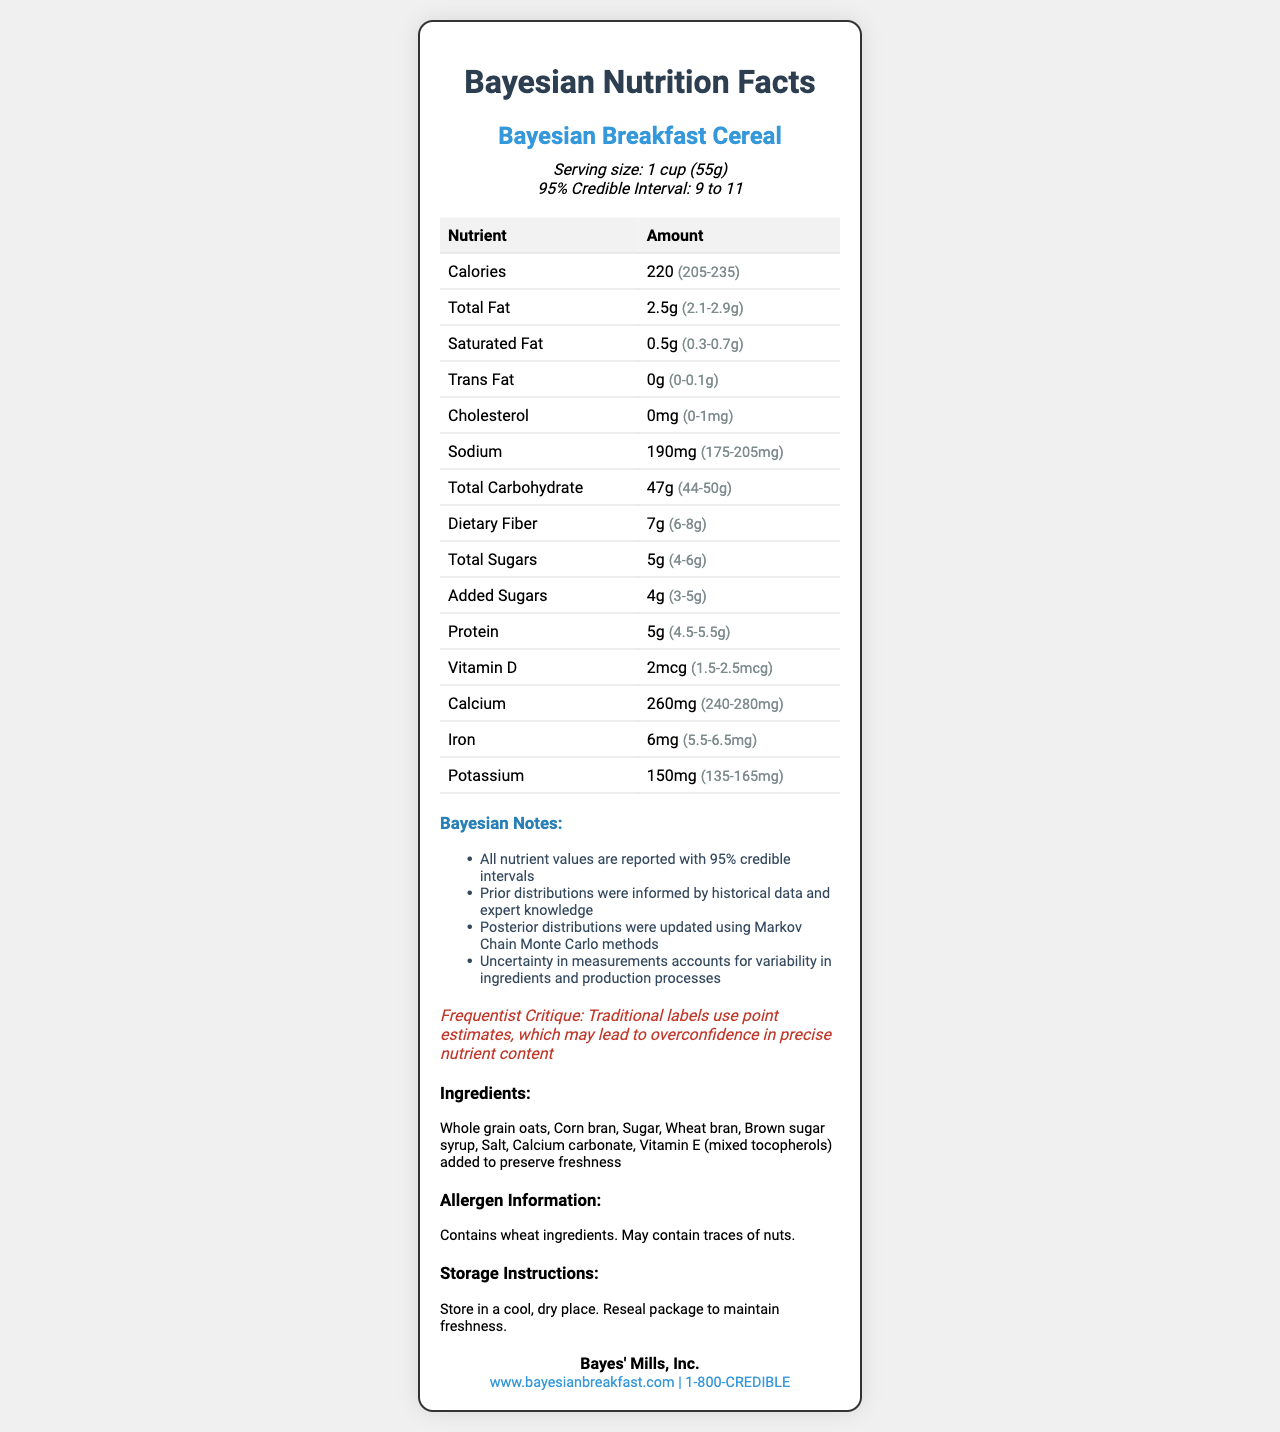What is the range of servings per container? The document states a 95% credible interval for servings per container, which ranges from 9 to 11.
Answer: 9 to 11 How many calories are in one serving of Bayesian Breakfast Cereal? The mean value of calories per serving is given as 220.
Answer: 220 What is the credible interval for total fat in grams? The credible interval for total fat is shown to be between 2.1 and 2.9 grams.
Answer: 2.1 to 2.9 grams What is the lower bound of the credible interval for dietary fiber? The lower bound of the credible interval for dietary fiber is explicitly stated as 6 grams.
Answer: 6 grams What method was used to update the posterior distributions? The bayesian notes mention that posterior distributions were updated using Markov Chain Monte Carlo methods.
Answer: Markov Chain Monte Carlo Which of the following nutrients has the widest credible interval? A. Calories B. Total Fat C. Vitamin D D. Sodium The calories have a credible interval of 205-235, which is a range of 30 units. This is wider than the intervals provided for other nutrients.
Answer: A. Calories What is the mean amount of protein in one serving? A. 4 grams B. 4.5 grams C. 5 grams D. 5.5 grams The mean amount of protein is given as 5 grams per serving.
Answer: C. 5 grams Is the credible interval for trans fat zero? The credible interval for trans fat is from 0 to 0.1 grams.
Answer: No Summarize the main idea of this document. The document gives a comprehensive overview of the nutritional content of the cereal, informed by Bayesian statistics and expressing uncertainty through credible intervals. This approach is contrasted with traditional point estimates, and further information about the product is provided.
Answer: This document provides the nutritional information for Bayesian Breakfast Cereal, including mean values and 95% credible intervals for various nutrients. It explains that the data are derived from Bayesian statistical methods, emphasizes the uncertainty inherent in the measurements, and critiques the point estimates provided by traditional labels. Additional details such as ingredients, allergens, storage instructions, manufacturer, and contact info are also provided. How much calcium is in one serving? The mean calcium content per serving is given as 260 mg.
Answer: 260 mg Why might credible intervals be preferred over point estimates for reporting nutrient content? Credible intervals provide a range of values that reflect uncertainty and variability due to ingredients and production processes, giving a more honest representation of the nutrient content.
Answer: They account for variability and uncertainty in measurements. What ingredient is used to preserve freshness? The ingredient listed to preserve freshness is Vitamin E (mixed tocopherols).
Answer: Vitamin E (mixed tocopherols) Does the cereal contain any traces of nuts? The allergen information states that the cereal may contain traces of nuts.
Answer: It may contain traces of nuts. What are the historical data and expert knowledge used for in the document? The bayesian notes explain that historical data and expert knowledge were used to inform the prior distributions in the Bayesian analysis.
Answer: To inform prior distributions What is the uncertainty critiqued in the frequentist approach? The frequentist critique mentions that traditional labels use point estimates, which may lead to overconfidence in the precise nutrient content.
Answer: Overconfidence in precise nutrient content What is the exact amount of dietary fiber in one serving? The exact amount cannot be determined since the document provides a mean value and a credible interval rather than a precise point estimate.
Answer: Cannot be determined What is the unit of measurement for Vitamin D? The unit of measurement for Vitamin D is given as micrograms (mcg).
Answer: mcg 